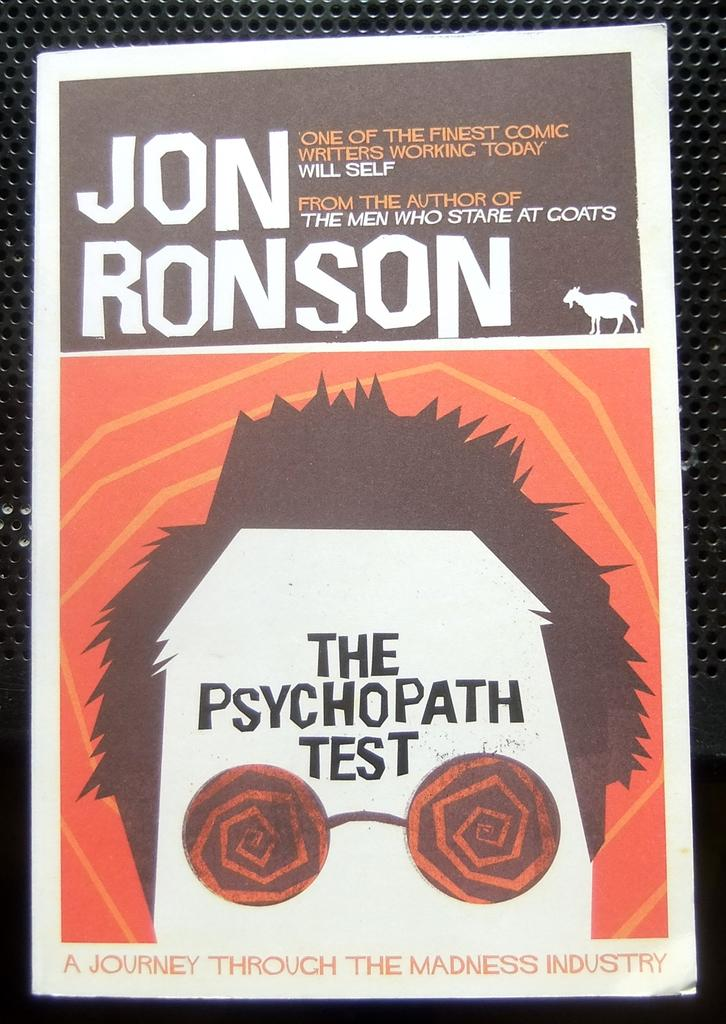<image>
Give a short and clear explanation of the subsequent image. a poste for jon ronsons the psychopath test with an orange background. 